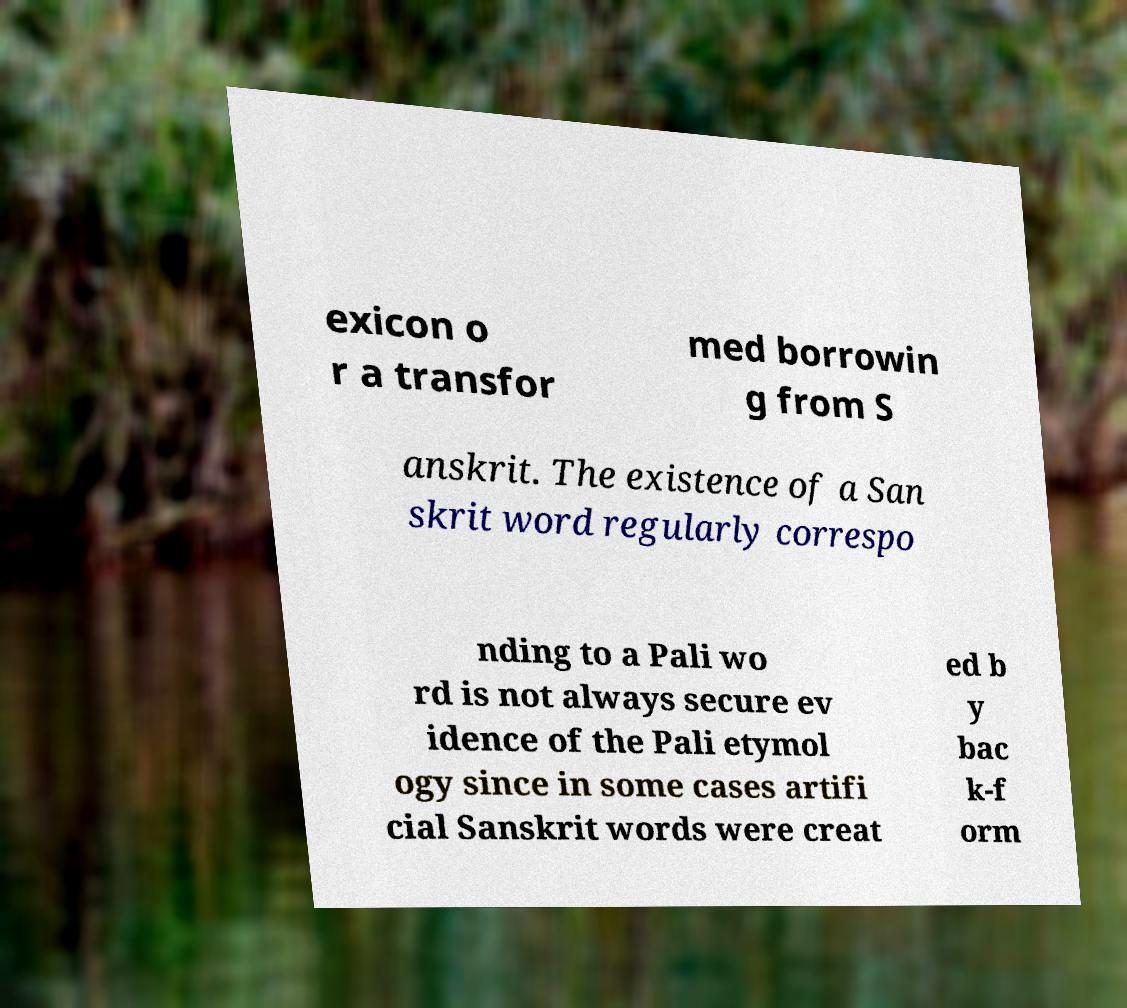Could you extract and type out the text from this image? exicon o r a transfor med borrowin g from S anskrit. The existence of a San skrit word regularly correspo nding to a Pali wo rd is not always secure ev idence of the Pali etymol ogy since in some cases artifi cial Sanskrit words were creat ed b y bac k-f orm 